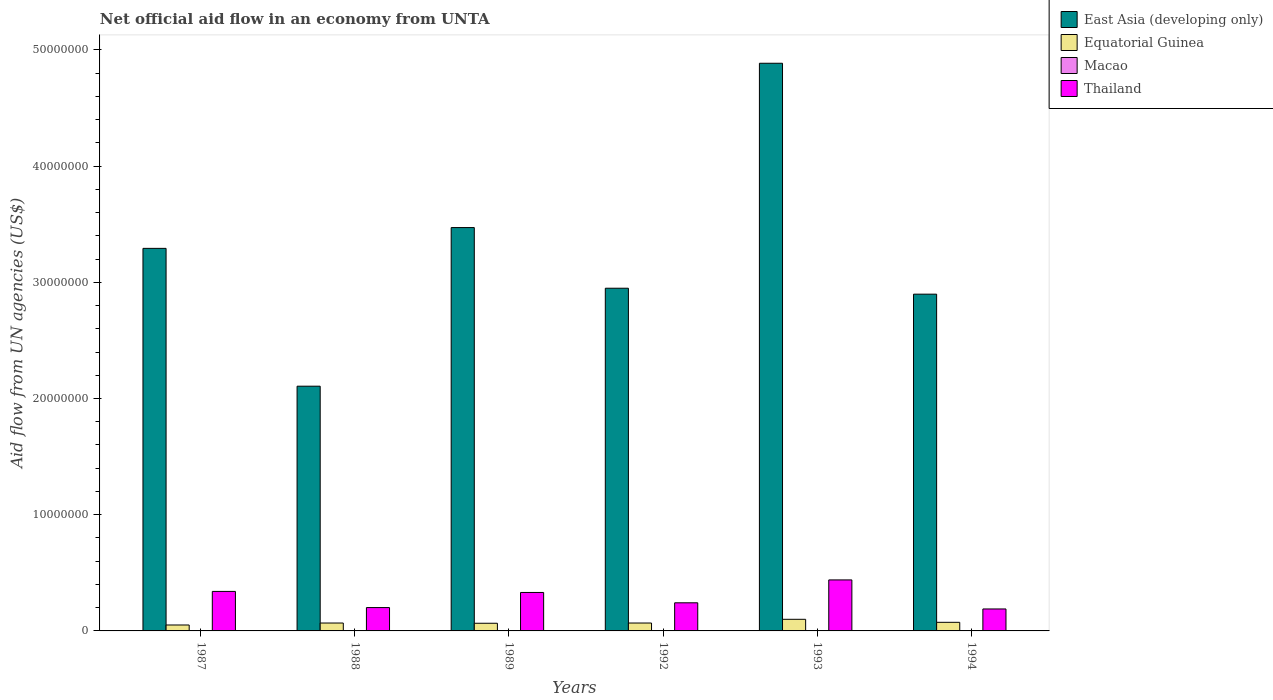How many different coloured bars are there?
Your response must be concise. 4. Are the number of bars on each tick of the X-axis equal?
Provide a short and direct response. Yes. How many bars are there on the 6th tick from the left?
Your answer should be very brief. 4. What is the net official aid flow in Thailand in 1987?
Your response must be concise. 3.40e+06. Across all years, what is the maximum net official aid flow in Thailand?
Provide a short and direct response. 4.39e+06. Across all years, what is the minimum net official aid flow in East Asia (developing only)?
Make the answer very short. 2.11e+07. In which year was the net official aid flow in Macao maximum?
Your response must be concise. 1987. What is the total net official aid flow in Macao in the graph?
Offer a terse response. 1.50e+05. What is the difference between the net official aid flow in Macao in 1987 and that in 1989?
Offer a very short reply. 0. What is the difference between the net official aid flow in Macao in 1988 and the net official aid flow in Thailand in 1989?
Your answer should be very brief. -3.28e+06. What is the average net official aid flow in East Asia (developing only) per year?
Your response must be concise. 3.27e+07. In the year 1989, what is the difference between the net official aid flow in Thailand and net official aid flow in Equatorial Guinea?
Give a very brief answer. 2.65e+06. In how many years, is the net official aid flow in Macao greater than 36000000 US$?
Your answer should be very brief. 0. Is the difference between the net official aid flow in Thailand in 1988 and 1989 greater than the difference between the net official aid flow in Equatorial Guinea in 1988 and 1989?
Keep it short and to the point. No. What is the difference between the highest and the second highest net official aid flow in Thailand?
Offer a very short reply. 9.90e+05. What is the difference between the highest and the lowest net official aid flow in East Asia (developing only)?
Ensure brevity in your answer.  2.78e+07. Is the sum of the net official aid flow in Equatorial Guinea in 1987 and 1992 greater than the maximum net official aid flow in Macao across all years?
Your response must be concise. Yes. Is it the case that in every year, the sum of the net official aid flow in East Asia (developing only) and net official aid flow in Thailand is greater than the sum of net official aid flow in Equatorial Guinea and net official aid flow in Macao?
Ensure brevity in your answer.  Yes. What does the 2nd bar from the left in 1993 represents?
Your answer should be compact. Equatorial Guinea. What does the 2nd bar from the right in 1988 represents?
Make the answer very short. Macao. How many bars are there?
Give a very brief answer. 24. What is the difference between two consecutive major ticks on the Y-axis?
Make the answer very short. 1.00e+07. Does the graph contain any zero values?
Offer a terse response. No. Does the graph contain grids?
Provide a succinct answer. No. How are the legend labels stacked?
Provide a short and direct response. Vertical. What is the title of the graph?
Ensure brevity in your answer.  Net official aid flow in an economy from UNTA. What is the label or title of the Y-axis?
Your answer should be compact. Aid flow from UN agencies (US$). What is the Aid flow from UN agencies (US$) in East Asia (developing only) in 1987?
Make the answer very short. 3.29e+07. What is the Aid flow from UN agencies (US$) of Equatorial Guinea in 1987?
Your answer should be very brief. 5.10e+05. What is the Aid flow from UN agencies (US$) in Macao in 1987?
Provide a short and direct response. 3.00e+04. What is the Aid flow from UN agencies (US$) of Thailand in 1987?
Make the answer very short. 3.40e+06. What is the Aid flow from UN agencies (US$) of East Asia (developing only) in 1988?
Keep it short and to the point. 2.11e+07. What is the Aid flow from UN agencies (US$) of Equatorial Guinea in 1988?
Your answer should be compact. 6.80e+05. What is the Aid flow from UN agencies (US$) in Macao in 1988?
Make the answer very short. 3.00e+04. What is the Aid flow from UN agencies (US$) in Thailand in 1988?
Your response must be concise. 2.01e+06. What is the Aid flow from UN agencies (US$) in East Asia (developing only) in 1989?
Make the answer very short. 3.47e+07. What is the Aid flow from UN agencies (US$) in Equatorial Guinea in 1989?
Your answer should be very brief. 6.60e+05. What is the Aid flow from UN agencies (US$) of Macao in 1989?
Provide a short and direct response. 3.00e+04. What is the Aid flow from UN agencies (US$) in Thailand in 1989?
Make the answer very short. 3.31e+06. What is the Aid flow from UN agencies (US$) of East Asia (developing only) in 1992?
Keep it short and to the point. 2.95e+07. What is the Aid flow from UN agencies (US$) of Equatorial Guinea in 1992?
Offer a very short reply. 6.80e+05. What is the Aid flow from UN agencies (US$) in Thailand in 1992?
Your answer should be very brief. 2.42e+06. What is the Aid flow from UN agencies (US$) of East Asia (developing only) in 1993?
Keep it short and to the point. 4.88e+07. What is the Aid flow from UN agencies (US$) of Equatorial Guinea in 1993?
Make the answer very short. 1.00e+06. What is the Aid flow from UN agencies (US$) of Macao in 1993?
Ensure brevity in your answer.  3.00e+04. What is the Aid flow from UN agencies (US$) in Thailand in 1993?
Provide a succinct answer. 4.39e+06. What is the Aid flow from UN agencies (US$) in East Asia (developing only) in 1994?
Keep it short and to the point. 2.90e+07. What is the Aid flow from UN agencies (US$) in Equatorial Guinea in 1994?
Your answer should be very brief. 7.40e+05. What is the Aid flow from UN agencies (US$) of Macao in 1994?
Give a very brief answer. 2.00e+04. What is the Aid flow from UN agencies (US$) of Thailand in 1994?
Keep it short and to the point. 1.89e+06. Across all years, what is the maximum Aid flow from UN agencies (US$) in East Asia (developing only)?
Your answer should be compact. 4.88e+07. Across all years, what is the maximum Aid flow from UN agencies (US$) in Thailand?
Provide a short and direct response. 4.39e+06. Across all years, what is the minimum Aid flow from UN agencies (US$) in East Asia (developing only)?
Provide a succinct answer. 2.11e+07. Across all years, what is the minimum Aid flow from UN agencies (US$) of Equatorial Guinea?
Make the answer very short. 5.10e+05. Across all years, what is the minimum Aid flow from UN agencies (US$) in Thailand?
Offer a terse response. 1.89e+06. What is the total Aid flow from UN agencies (US$) of East Asia (developing only) in the graph?
Ensure brevity in your answer.  1.96e+08. What is the total Aid flow from UN agencies (US$) of Equatorial Guinea in the graph?
Your answer should be compact. 4.27e+06. What is the total Aid flow from UN agencies (US$) of Macao in the graph?
Give a very brief answer. 1.50e+05. What is the total Aid flow from UN agencies (US$) of Thailand in the graph?
Provide a succinct answer. 1.74e+07. What is the difference between the Aid flow from UN agencies (US$) in East Asia (developing only) in 1987 and that in 1988?
Your response must be concise. 1.19e+07. What is the difference between the Aid flow from UN agencies (US$) in Thailand in 1987 and that in 1988?
Your answer should be very brief. 1.39e+06. What is the difference between the Aid flow from UN agencies (US$) in East Asia (developing only) in 1987 and that in 1989?
Keep it short and to the point. -1.79e+06. What is the difference between the Aid flow from UN agencies (US$) in Macao in 1987 and that in 1989?
Provide a short and direct response. 0. What is the difference between the Aid flow from UN agencies (US$) of East Asia (developing only) in 1987 and that in 1992?
Offer a very short reply. 3.43e+06. What is the difference between the Aid flow from UN agencies (US$) in Equatorial Guinea in 1987 and that in 1992?
Provide a succinct answer. -1.70e+05. What is the difference between the Aid flow from UN agencies (US$) of Thailand in 1987 and that in 1992?
Your answer should be very brief. 9.80e+05. What is the difference between the Aid flow from UN agencies (US$) of East Asia (developing only) in 1987 and that in 1993?
Provide a short and direct response. -1.59e+07. What is the difference between the Aid flow from UN agencies (US$) of Equatorial Guinea in 1987 and that in 1993?
Make the answer very short. -4.90e+05. What is the difference between the Aid flow from UN agencies (US$) in Thailand in 1987 and that in 1993?
Give a very brief answer. -9.90e+05. What is the difference between the Aid flow from UN agencies (US$) in East Asia (developing only) in 1987 and that in 1994?
Give a very brief answer. 3.94e+06. What is the difference between the Aid flow from UN agencies (US$) in Macao in 1987 and that in 1994?
Offer a terse response. 10000. What is the difference between the Aid flow from UN agencies (US$) of Thailand in 1987 and that in 1994?
Your answer should be compact. 1.51e+06. What is the difference between the Aid flow from UN agencies (US$) of East Asia (developing only) in 1988 and that in 1989?
Your response must be concise. -1.36e+07. What is the difference between the Aid flow from UN agencies (US$) of Equatorial Guinea in 1988 and that in 1989?
Your response must be concise. 2.00e+04. What is the difference between the Aid flow from UN agencies (US$) in Thailand in 1988 and that in 1989?
Make the answer very short. -1.30e+06. What is the difference between the Aid flow from UN agencies (US$) of East Asia (developing only) in 1988 and that in 1992?
Your answer should be compact. -8.43e+06. What is the difference between the Aid flow from UN agencies (US$) of Equatorial Guinea in 1988 and that in 1992?
Keep it short and to the point. 0. What is the difference between the Aid flow from UN agencies (US$) of Thailand in 1988 and that in 1992?
Ensure brevity in your answer.  -4.10e+05. What is the difference between the Aid flow from UN agencies (US$) of East Asia (developing only) in 1988 and that in 1993?
Offer a very short reply. -2.78e+07. What is the difference between the Aid flow from UN agencies (US$) of Equatorial Guinea in 1988 and that in 1993?
Your response must be concise. -3.20e+05. What is the difference between the Aid flow from UN agencies (US$) of Macao in 1988 and that in 1993?
Provide a succinct answer. 0. What is the difference between the Aid flow from UN agencies (US$) in Thailand in 1988 and that in 1993?
Offer a terse response. -2.38e+06. What is the difference between the Aid flow from UN agencies (US$) of East Asia (developing only) in 1988 and that in 1994?
Provide a short and direct response. -7.92e+06. What is the difference between the Aid flow from UN agencies (US$) in Macao in 1988 and that in 1994?
Offer a very short reply. 10000. What is the difference between the Aid flow from UN agencies (US$) of Thailand in 1988 and that in 1994?
Provide a succinct answer. 1.20e+05. What is the difference between the Aid flow from UN agencies (US$) in East Asia (developing only) in 1989 and that in 1992?
Give a very brief answer. 5.22e+06. What is the difference between the Aid flow from UN agencies (US$) in Thailand in 1989 and that in 1992?
Your response must be concise. 8.90e+05. What is the difference between the Aid flow from UN agencies (US$) in East Asia (developing only) in 1989 and that in 1993?
Your answer should be compact. -1.41e+07. What is the difference between the Aid flow from UN agencies (US$) of Macao in 1989 and that in 1993?
Make the answer very short. 0. What is the difference between the Aid flow from UN agencies (US$) in Thailand in 1989 and that in 1993?
Keep it short and to the point. -1.08e+06. What is the difference between the Aid flow from UN agencies (US$) of East Asia (developing only) in 1989 and that in 1994?
Make the answer very short. 5.73e+06. What is the difference between the Aid flow from UN agencies (US$) of Equatorial Guinea in 1989 and that in 1994?
Provide a succinct answer. -8.00e+04. What is the difference between the Aid flow from UN agencies (US$) of Thailand in 1989 and that in 1994?
Your answer should be compact. 1.42e+06. What is the difference between the Aid flow from UN agencies (US$) in East Asia (developing only) in 1992 and that in 1993?
Give a very brief answer. -1.94e+07. What is the difference between the Aid flow from UN agencies (US$) of Equatorial Guinea in 1992 and that in 1993?
Offer a terse response. -3.20e+05. What is the difference between the Aid flow from UN agencies (US$) in Thailand in 1992 and that in 1993?
Your answer should be compact. -1.97e+06. What is the difference between the Aid flow from UN agencies (US$) of East Asia (developing only) in 1992 and that in 1994?
Give a very brief answer. 5.10e+05. What is the difference between the Aid flow from UN agencies (US$) of Thailand in 1992 and that in 1994?
Your response must be concise. 5.30e+05. What is the difference between the Aid flow from UN agencies (US$) of East Asia (developing only) in 1993 and that in 1994?
Ensure brevity in your answer.  1.99e+07. What is the difference between the Aid flow from UN agencies (US$) in Thailand in 1993 and that in 1994?
Give a very brief answer. 2.50e+06. What is the difference between the Aid flow from UN agencies (US$) of East Asia (developing only) in 1987 and the Aid flow from UN agencies (US$) of Equatorial Guinea in 1988?
Your answer should be compact. 3.22e+07. What is the difference between the Aid flow from UN agencies (US$) of East Asia (developing only) in 1987 and the Aid flow from UN agencies (US$) of Macao in 1988?
Provide a succinct answer. 3.29e+07. What is the difference between the Aid flow from UN agencies (US$) of East Asia (developing only) in 1987 and the Aid flow from UN agencies (US$) of Thailand in 1988?
Keep it short and to the point. 3.09e+07. What is the difference between the Aid flow from UN agencies (US$) in Equatorial Guinea in 1987 and the Aid flow from UN agencies (US$) in Macao in 1988?
Offer a terse response. 4.80e+05. What is the difference between the Aid flow from UN agencies (US$) of Equatorial Guinea in 1987 and the Aid flow from UN agencies (US$) of Thailand in 1988?
Your response must be concise. -1.50e+06. What is the difference between the Aid flow from UN agencies (US$) of Macao in 1987 and the Aid flow from UN agencies (US$) of Thailand in 1988?
Your answer should be very brief. -1.98e+06. What is the difference between the Aid flow from UN agencies (US$) in East Asia (developing only) in 1987 and the Aid flow from UN agencies (US$) in Equatorial Guinea in 1989?
Give a very brief answer. 3.23e+07. What is the difference between the Aid flow from UN agencies (US$) of East Asia (developing only) in 1987 and the Aid flow from UN agencies (US$) of Macao in 1989?
Offer a very short reply. 3.29e+07. What is the difference between the Aid flow from UN agencies (US$) of East Asia (developing only) in 1987 and the Aid flow from UN agencies (US$) of Thailand in 1989?
Make the answer very short. 2.96e+07. What is the difference between the Aid flow from UN agencies (US$) in Equatorial Guinea in 1987 and the Aid flow from UN agencies (US$) in Macao in 1989?
Provide a short and direct response. 4.80e+05. What is the difference between the Aid flow from UN agencies (US$) in Equatorial Guinea in 1987 and the Aid flow from UN agencies (US$) in Thailand in 1989?
Your response must be concise. -2.80e+06. What is the difference between the Aid flow from UN agencies (US$) in Macao in 1987 and the Aid flow from UN agencies (US$) in Thailand in 1989?
Give a very brief answer. -3.28e+06. What is the difference between the Aid flow from UN agencies (US$) of East Asia (developing only) in 1987 and the Aid flow from UN agencies (US$) of Equatorial Guinea in 1992?
Ensure brevity in your answer.  3.22e+07. What is the difference between the Aid flow from UN agencies (US$) in East Asia (developing only) in 1987 and the Aid flow from UN agencies (US$) in Macao in 1992?
Your answer should be very brief. 3.29e+07. What is the difference between the Aid flow from UN agencies (US$) of East Asia (developing only) in 1987 and the Aid flow from UN agencies (US$) of Thailand in 1992?
Your response must be concise. 3.05e+07. What is the difference between the Aid flow from UN agencies (US$) in Equatorial Guinea in 1987 and the Aid flow from UN agencies (US$) in Macao in 1992?
Provide a succinct answer. 5.00e+05. What is the difference between the Aid flow from UN agencies (US$) of Equatorial Guinea in 1987 and the Aid flow from UN agencies (US$) of Thailand in 1992?
Offer a very short reply. -1.91e+06. What is the difference between the Aid flow from UN agencies (US$) of Macao in 1987 and the Aid flow from UN agencies (US$) of Thailand in 1992?
Offer a terse response. -2.39e+06. What is the difference between the Aid flow from UN agencies (US$) of East Asia (developing only) in 1987 and the Aid flow from UN agencies (US$) of Equatorial Guinea in 1993?
Give a very brief answer. 3.19e+07. What is the difference between the Aid flow from UN agencies (US$) in East Asia (developing only) in 1987 and the Aid flow from UN agencies (US$) in Macao in 1993?
Ensure brevity in your answer.  3.29e+07. What is the difference between the Aid flow from UN agencies (US$) in East Asia (developing only) in 1987 and the Aid flow from UN agencies (US$) in Thailand in 1993?
Give a very brief answer. 2.85e+07. What is the difference between the Aid flow from UN agencies (US$) of Equatorial Guinea in 1987 and the Aid flow from UN agencies (US$) of Macao in 1993?
Keep it short and to the point. 4.80e+05. What is the difference between the Aid flow from UN agencies (US$) in Equatorial Guinea in 1987 and the Aid flow from UN agencies (US$) in Thailand in 1993?
Ensure brevity in your answer.  -3.88e+06. What is the difference between the Aid flow from UN agencies (US$) in Macao in 1987 and the Aid flow from UN agencies (US$) in Thailand in 1993?
Make the answer very short. -4.36e+06. What is the difference between the Aid flow from UN agencies (US$) of East Asia (developing only) in 1987 and the Aid flow from UN agencies (US$) of Equatorial Guinea in 1994?
Your response must be concise. 3.22e+07. What is the difference between the Aid flow from UN agencies (US$) in East Asia (developing only) in 1987 and the Aid flow from UN agencies (US$) in Macao in 1994?
Your response must be concise. 3.29e+07. What is the difference between the Aid flow from UN agencies (US$) of East Asia (developing only) in 1987 and the Aid flow from UN agencies (US$) of Thailand in 1994?
Provide a succinct answer. 3.10e+07. What is the difference between the Aid flow from UN agencies (US$) in Equatorial Guinea in 1987 and the Aid flow from UN agencies (US$) in Macao in 1994?
Give a very brief answer. 4.90e+05. What is the difference between the Aid flow from UN agencies (US$) in Equatorial Guinea in 1987 and the Aid flow from UN agencies (US$) in Thailand in 1994?
Give a very brief answer. -1.38e+06. What is the difference between the Aid flow from UN agencies (US$) of Macao in 1987 and the Aid flow from UN agencies (US$) of Thailand in 1994?
Offer a terse response. -1.86e+06. What is the difference between the Aid flow from UN agencies (US$) of East Asia (developing only) in 1988 and the Aid flow from UN agencies (US$) of Equatorial Guinea in 1989?
Offer a very short reply. 2.04e+07. What is the difference between the Aid flow from UN agencies (US$) of East Asia (developing only) in 1988 and the Aid flow from UN agencies (US$) of Macao in 1989?
Your answer should be compact. 2.10e+07. What is the difference between the Aid flow from UN agencies (US$) of East Asia (developing only) in 1988 and the Aid flow from UN agencies (US$) of Thailand in 1989?
Give a very brief answer. 1.78e+07. What is the difference between the Aid flow from UN agencies (US$) of Equatorial Guinea in 1988 and the Aid flow from UN agencies (US$) of Macao in 1989?
Provide a short and direct response. 6.50e+05. What is the difference between the Aid flow from UN agencies (US$) of Equatorial Guinea in 1988 and the Aid flow from UN agencies (US$) of Thailand in 1989?
Offer a very short reply. -2.63e+06. What is the difference between the Aid flow from UN agencies (US$) of Macao in 1988 and the Aid flow from UN agencies (US$) of Thailand in 1989?
Offer a very short reply. -3.28e+06. What is the difference between the Aid flow from UN agencies (US$) of East Asia (developing only) in 1988 and the Aid flow from UN agencies (US$) of Equatorial Guinea in 1992?
Offer a terse response. 2.04e+07. What is the difference between the Aid flow from UN agencies (US$) of East Asia (developing only) in 1988 and the Aid flow from UN agencies (US$) of Macao in 1992?
Provide a short and direct response. 2.10e+07. What is the difference between the Aid flow from UN agencies (US$) in East Asia (developing only) in 1988 and the Aid flow from UN agencies (US$) in Thailand in 1992?
Provide a succinct answer. 1.86e+07. What is the difference between the Aid flow from UN agencies (US$) of Equatorial Guinea in 1988 and the Aid flow from UN agencies (US$) of Macao in 1992?
Provide a succinct answer. 6.70e+05. What is the difference between the Aid flow from UN agencies (US$) in Equatorial Guinea in 1988 and the Aid flow from UN agencies (US$) in Thailand in 1992?
Offer a very short reply. -1.74e+06. What is the difference between the Aid flow from UN agencies (US$) in Macao in 1988 and the Aid flow from UN agencies (US$) in Thailand in 1992?
Keep it short and to the point. -2.39e+06. What is the difference between the Aid flow from UN agencies (US$) in East Asia (developing only) in 1988 and the Aid flow from UN agencies (US$) in Equatorial Guinea in 1993?
Provide a succinct answer. 2.01e+07. What is the difference between the Aid flow from UN agencies (US$) of East Asia (developing only) in 1988 and the Aid flow from UN agencies (US$) of Macao in 1993?
Provide a short and direct response. 2.10e+07. What is the difference between the Aid flow from UN agencies (US$) of East Asia (developing only) in 1988 and the Aid flow from UN agencies (US$) of Thailand in 1993?
Provide a succinct answer. 1.67e+07. What is the difference between the Aid flow from UN agencies (US$) of Equatorial Guinea in 1988 and the Aid flow from UN agencies (US$) of Macao in 1993?
Your answer should be compact. 6.50e+05. What is the difference between the Aid flow from UN agencies (US$) in Equatorial Guinea in 1988 and the Aid flow from UN agencies (US$) in Thailand in 1993?
Make the answer very short. -3.71e+06. What is the difference between the Aid flow from UN agencies (US$) in Macao in 1988 and the Aid flow from UN agencies (US$) in Thailand in 1993?
Make the answer very short. -4.36e+06. What is the difference between the Aid flow from UN agencies (US$) of East Asia (developing only) in 1988 and the Aid flow from UN agencies (US$) of Equatorial Guinea in 1994?
Provide a succinct answer. 2.03e+07. What is the difference between the Aid flow from UN agencies (US$) of East Asia (developing only) in 1988 and the Aid flow from UN agencies (US$) of Macao in 1994?
Offer a terse response. 2.10e+07. What is the difference between the Aid flow from UN agencies (US$) in East Asia (developing only) in 1988 and the Aid flow from UN agencies (US$) in Thailand in 1994?
Make the answer very short. 1.92e+07. What is the difference between the Aid flow from UN agencies (US$) in Equatorial Guinea in 1988 and the Aid flow from UN agencies (US$) in Thailand in 1994?
Provide a succinct answer. -1.21e+06. What is the difference between the Aid flow from UN agencies (US$) in Macao in 1988 and the Aid flow from UN agencies (US$) in Thailand in 1994?
Provide a short and direct response. -1.86e+06. What is the difference between the Aid flow from UN agencies (US$) in East Asia (developing only) in 1989 and the Aid flow from UN agencies (US$) in Equatorial Guinea in 1992?
Make the answer very short. 3.40e+07. What is the difference between the Aid flow from UN agencies (US$) of East Asia (developing only) in 1989 and the Aid flow from UN agencies (US$) of Macao in 1992?
Provide a succinct answer. 3.47e+07. What is the difference between the Aid flow from UN agencies (US$) in East Asia (developing only) in 1989 and the Aid flow from UN agencies (US$) in Thailand in 1992?
Offer a very short reply. 3.23e+07. What is the difference between the Aid flow from UN agencies (US$) of Equatorial Guinea in 1989 and the Aid flow from UN agencies (US$) of Macao in 1992?
Make the answer very short. 6.50e+05. What is the difference between the Aid flow from UN agencies (US$) in Equatorial Guinea in 1989 and the Aid flow from UN agencies (US$) in Thailand in 1992?
Provide a short and direct response. -1.76e+06. What is the difference between the Aid flow from UN agencies (US$) in Macao in 1989 and the Aid flow from UN agencies (US$) in Thailand in 1992?
Your response must be concise. -2.39e+06. What is the difference between the Aid flow from UN agencies (US$) of East Asia (developing only) in 1989 and the Aid flow from UN agencies (US$) of Equatorial Guinea in 1993?
Make the answer very short. 3.37e+07. What is the difference between the Aid flow from UN agencies (US$) in East Asia (developing only) in 1989 and the Aid flow from UN agencies (US$) in Macao in 1993?
Provide a short and direct response. 3.47e+07. What is the difference between the Aid flow from UN agencies (US$) of East Asia (developing only) in 1989 and the Aid flow from UN agencies (US$) of Thailand in 1993?
Your answer should be very brief. 3.03e+07. What is the difference between the Aid flow from UN agencies (US$) in Equatorial Guinea in 1989 and the Aid flow from UN agencies (US$) in Macao in 1993?
Ensure brevity in your answer.  6.30e+05. What is the difference between the Aid flow from UN agencies (US$) in Equatorial Guinea in 1989 and the Aid flow from UN agencies (US$) in Thailand in 1993?
Your response must be concise. -3.73e+06. What is the difference between the Aid flow from UN agencies (US$) of Macao in 1989 and the Aid flow from UN agencies (US$) of Thailand in 1993?
Offer a terse response. -4.36e+06. What is the difference between the Aid flow from UN agencies (US$) in East Asia (developing only) in 1989 and the Aid flow from UN agencies (US$) in Equatorial Guinea in 1994?
Keep it short and to the point. 3.40e+07. What is the difference between the Aid flow from UN agencies (US$) in East Asia (developing only) in 1989 and the Aid flow from UN agencies (US$) in Macao in 1994?
Provide a succinct answer. 3.47e+07. What is the difference between the Aid flow from UN agencies (US$) in East Asia (developing only) in 1989 and the Aid flow from UN agencies (US$) in Thailand in 1994?
Make the answer very short. 3.28e+07. What is the difference between the Aid flow from UN agencies (US$) of Equatorial Guinea in 1989 and the Aid flow from UN agencies (US$) of Macao in 1994?
Give a very brief answer. 6.40e+05. What is the difference between the Aid flow from UN agencies (US$) in Equatorial Guinea in 1989 and the Aid flow from UN agencies (US$) in Thailand in 1994?
Your answer should be very brief. -1.23e+06. What is the difference between the Aid flow from UN agencies (US$) in Macao in 1989 and the Aid flow from UN agencies (US$) in Thailand in 1994?
Keep it short and to the point. -1.86e+06. What is the difference between the Aid flow from UN agencies (US$) in East Asia (developing only) in 1992 and the Aid flow from UN agencies (US$) in Equatorial Guinea in 1993?
Keep it short and to the point. 2.85e+07. What is the difference between the Aid flow from UN agencies (US$) of East Asia (developing only) in 1992 and the Aid flow from UN agencies (US$) of Macao in 1993?
Your answer should be compact. 2.95e+07. What is the difference between the Aid flow from UN agencies (US$) of East Asia (developing only) in 1992 and the Aid flow from UN agencies (US$) of Thailand in 1993?
Give a very brief answer. 2.51e+07. What is the difference between the Aid flow from UN agencies (US$) of Equatorial Guinea in 1992 and the Aid flow from UN agencies (US$) of Macao in 1993?
Keep it short and to the point. 6.50e+05. What is the difference between the Aid flow from UN agencies (US$) of Equatorial Guinea in 1992 and the Aid flow from UN agencies (US$) of Thailand in 1993?
Offer a terse response. -3.71e+06. What is the difference between the Aid flow from UN agencies (US$) of Macao in 1992 and the Aid flow from UN agencies (US$) of Thailand in 1993?
Your response must be concise. -4.38e+06. What is the difference between the Aid flow from UN agencies (US$) of East Asia (developing only) in 1992 and the Aid flow from UN agencies (US$) of Equatorial Guinea in 1994?
Your answer should be very brief. 2.88e+07. What is the difference between the Aid flow from UN agencies (US$) in East Asia (developing only) in 1992 and the Aid flow from UN agencies (US$) in Macao in 1994?
Ensure brevity in your answer.  2.95e+07. What is the difference between the Aid flow from UN agencies (US$) in East Asia (developing only) in 1992 and the Aid flow from UN agencies (US$) in Thailand in 1994?
Your response must be concise. 2.76e+07. What is the difference between the Aid flow from UN agencies (US$) of Equatorial Guinea in 1992 and the Aid flow from UN agencies (US$) of Macao in 1994?
Your response must be concise. 6.60e+05. What is the difference between the Aid flow from UN agencies (US$) of Equatorial Guinea in 1992 and the Aid flow from UN agencies (US$) of Thailand in 1994?
Provide a succinct answer. -1.21e+06. What is the difference between the Aid flow from UN agencies (US$) in Macao in 1992 and the Aid flow from UN agencies (US$) in Thailand in 1994?
Keep it short and to the point. -1.88e+06. What is the difference between the Aid flow from UN agencies (US$) of East Asia (developing only) in 1993 and the Aid flow from UN agencies (US$) of Equatorial Guinea in 1994?
Offer a very short reply. 4.81e+07. What is the difference between the Aid flow from UN agencies (US$) of East Asia (developing only) in 1993 and the Aid flow from UN agencies (US$) of Macao in 1994?
Your answer should be very brief. 4.88e+07. What is the difference between the Aid flow from UN agencies (US$) in East Asia (developing only) in 1993 and the Aid flow from UN agencies (US$) in Thailand in 1994?
Keep it short and to the point. 4.70e+07. What is the difference between the Aid flow from UN agencies (US$) of Equatorial Guinea in 1993 and the Aid flow from UN agencies (US$) of Macao in 1994?
Your response must be concise. 9.80e+05. What is the difference between the Aid flow from UN agencies (US$) in Equatorial Guinea in 1993 and the Aid flow from UN agencies (US$) in Thailand in 1994?
Your answer should be compact. -8.90e+05. What is the difference between the Aid flow from UN agencies (US$) of Macao in 1993 and the Aid flow from UN agencies (US$) of Thailand in 1994?
Your response must be concise. -1.86e+06. What is the average Aid flow from UN agencies (US$) in East Asia (developing only) per year?
Keep it short and to the point. 3.27e+07. What is the average Aid flow from UN agencies (US$) of Equatorial Guinea per year?
Give a very brief answer. 7.12e+05. What is the average Aid flow from UN agencies (US$) in Macao per year?
Ensure brevity in your answer.  2.50e+04. What is the average Aid flow from UN agencies (US$) of Thailand per year?
Your answer should be compact. 2.90e+06. In the year 1987, what is the difference between the Aid flow from UN agencies (US$) of East Asia (developing only) and Aid flow from UN agencies (US$) of Equatorial Guinea?
Give a very brief answer. 3.24e+07. In the year 1987, what is the difference between the Aid flow from UN agencies (US$) of East Asia (developing only) and Aid flow from UN agencies (US$) of Macao?
Keep it short and to the point. 3.29e+07. In the year 1987, what is the difference between the Aid flow from UN agencies (US$) in East Asia (developing only) and Aid flow from UN agencies (US$) in Thailand?
Offer a very short reply. 2.95e+07. In the year 1987, what is the difference between the Aid flow from UN agencies (US$) in Equatorial Guinea and Aid flow from UN agencies (US$) in Thailand?
Offer a terse response. -2.89e+06. In the year 1987, what is the difference between the Aid flow from UN agencies (US$) of Macao and Aid flow from UN agencies (US$) of Thailand?
Your response must be concise. -3.37e+06. In the year 1988, what is the difference between the Aid flow from UN agencies (US$) in East Asia (developing only) and Aid flow from UN agencies (US$) in Equatorial Guinea?
Make the answer very short. 2.04e+07. In the year 1988, what is the difference between the Aid flow from UN agencies (US$) of East Asia (developing only) and Aid flow from UN agencies (US$) of Macao?
Provide a short and direct response. 2.10e+07. In the year 1988, what is the difference between the Aid flow from UN agencies (US$) in East Asia (developing only) and Aid flow from UN agencies (US$) in Thailand?
Keep it short and to the point. 1.90e+07. In the year 1988, what is the difference between the Aid flow from UN agencies (US$) in Equatorial Guinea and Aid flow from UN agencies (US$) in Macao?
Your answer should be very brief. 6.50e+05. In the year 1988, what is the difference between the Aid flow from UN agencies (US$) of Equatorial Guinea and Aid flow from UN agencies (US$) of Thailand?
Your response must be concise. -1.33e+06. In the year 1988, what is the difference between the Aid flow from UN agencies (US$) in Macao and Aid flow from UN agencies (US$) in Thailand?
Your answer should be compact. -1.98e+06. In the year 1989, what is the difference between the Aid flow from UN agencies (US$) of East Asia (developing only) and Aid flow from UN agencies (US$) of Equatorial Guinea?
Your answer should be compact. 3.40e+07. In the year 1989, what is the difference between the Aid flow from UN agencies (US$) in East Asia (developing only) and Aid flow from UN agencies (US$) in Macao?
Your response must be concise. 3.47e+07. In the year 1989, what is the difference between the Aid flow from UN agencies (US$) in East Asia (developing only) and Aid flow from UN agencies (US$) in Thailand?
Ensure brevity in your answer.  3.14e+07. In the year 1989, what is the difference between the Aid flow from UN agencies (US$) in Equatorial Guinea and Aid flow from UN agencies (US$) in Macao?
Your answer should be very brief. 6.30e+05. In the year 1989, what is the difference between the Aid flow from UN agencies (US$) of Equatorial Guinea and Aid flow from UN agencies (US$) of Thailand?
Provide a succinct answer. -2.65e+06. In the year 1989, what is the difference between the Aid flow from UN agencies (US$) in Macao and Aid flow from UN agencies (US$) in Thailand?
Provide a short and direct response. -3.28e+06. In the year 1992, what is the difference between the Aid flow from UN agencies (US$) of East Asia (developing only) and Aid flow from UN agencies (US$) of Equatorial Guinea?
Offer a very short reply. 2.88e+07. In the year 1992, what is the difference between the Aid flow from UN agencies (US$) of East Asia (developing only) and Aid flow from UN agencies (US$) of Macao?
Provide a short and direct response. 2.95e+07. In the year 1992, what is the difference between the Aid flow from UN agencies (US$) of East Asia (developing only) and Aid flow from UN agencies (US$) of Thailand?
Your answer should be very brief. 2.71e+07. In the year 1992, what is the difference between the Aid flow from UN agencies (US$) in Equatorial Guinea and Aid flow from UN agencies (US$) in Macao?
Give a very brief answer. 6.70e+05. In the year 1992, what is the difference between the Aid flow from UN agencies (US$) of Equatorial Guinea and Aid flow from UN agencies (US$) of Thailand?
Offer a very short reply. -1.74e+06. In the year 1992, what is the difference between the Aid flow from UN agencies (US$) in Macao and Aid flow from UN agencies (US$) in Thailand?
Ensure brevity in your answer.  -2.41e+06. In the year 1993, what is the difference between the Aid flow from UN agencies (US$) in East Asia (developing only) and Aid flow from UN agencies (US$) in Equatorial Guinea?
Provide a succinct answer. 4.78e+07. In the year 1993, what is the difference between the Aid flow from UN agencies (US$) in East Asia (developing only) and Aid flow from UN agencies (US$) in Macao?
Offer a very short reply. 4.88e+07. In the year 1993, what is the difference between the Aid flow from UN agencies (US$) in East Asia (developing only) and Aid flow from UN agencies (US$) in Thailand?
Offer a terse response. 4.45e+07. In the year 1993, what is the difference between the Aid flow from UN agencies (US$) of Equatorial Guinea and Aid flow from UN agencies (US$) of Macao?
Your answer should be compact. 9.70e+05. In the year 1993, what is the difference between the Aid flow from UN agencies (US$) of Equatorial Guinea and Aid flow from UN agencies (US$) of Thailand?
Provide a succinct answer. -3.39e+06. In the year 1993, what is the difference between the Aid flow from UN agencies (US$) in Macao and Aid flow from UN agencies (US$) in Thailand?
Make the answer very short. -4.36e+06. In the year 1994, what is the difference between the Aid flow from UN agencies (US$) of East Asia (developing only) and Aid flow from UN agencies (US$) of Equatorial Guinea?
Give a very brief answer. 2.82e+07. In the year 1994, what is the difference between the Aid flow from UN agencies (US$) of East Asia (developing only) and Aid flow from UN agencies (US$) of Macao?
Give a very brief answer. 2.90e+07. In the year 1994, what is the difference between the Aid flow from UN agencies (US$) in East Asia (developing only) and Aid flow from UN agencies (US$) in Thailand?
Your answer should be very brief. 2.71e+07. In the year 1994, what is the difference between the Aid flow from UN agencies (US$) of Equatorial Guinea and Aid flow from UN agencies (US$) of Macao?
Offer a very short reply. 7.20e+05. In the year 1994, what is the difference between the Aid flow from UN agencies (US$) in Equatorial Guinea and Aid flow from UN agencies (US$) in Thailand?
Your answer should be compact. -1.15e+06. In the year 1994, what is the difference between the Aid flow from UN agencies (US$) in Macao and Aid flow from UN agencies (US$) in Thailand?
Offer a terse response. -1.87e+06. What is the ratio of the Aid flow from UN agencies (US$) of East Asia (developing only) in 1987 to that in 1988?
Make the answer very short. 1.56. What is the ratio of the Aid flow from UN agencies (US$) in Equatorial Guinea in 1987 to that in 1988?
Offer a very short reply. 0.75. What is the ratio of the Aid flow from UN agencies (US$) of Macao in 1987 to that in 1988?
Your answer should be compact. 1. What is the ratio of the Aid flow from UN agencies (US$) in Thailand in 1987 to that in 1988?
Your response must be concise. 1.69. What is the ratio of the Aid flow from UN agencies (US$) in East Asia (developing only) in 1987 to that in 1989?
Ensure brevity in your answer.  0.95. What is the ratio of the Aid flow from UN agencies (US$) in Equatorial Guinea in 1987 to that in 1989?
Give a very brief answer. 0.77. What is the ratio of the Aid flow from UN agencies (US$) in Thailand in 1987 to that in 1989?
Ensure brevity in your answer.  1.03. What is the ratio of the Aid flow from UN agencies (US$) of East Asia (developing only) in 1987 to that in 1992?
Your response must be concise. 1.12. What is the ratio of the Aid flow from UN agencies (US$) in Macao in 1987 to that in 1992?
Offer a very short reply. 3. What is the ratio of the Aid flow from UN agencies (US$) of Thailand in 1987 to that in 1992?
Offer a terse response. 1.41. What is the ratio of the Aid flow from UN agencies (US$) in East Asia (developing only) in 1987 to that in 1993?
Provide a succinct answer. 0.67. What is the ratio of the Aid flow from UN agencies (US$) of Equatorial Guinea in 1987 to that in 1993?
Your answer should be compact. 0.51. What is the ratio of the Aid flow from UN agencies (US$) of Thailand in 1987 to that in 1993?
Make the answer very short. 0.77. What is the ratio of the Aid flow from UN agencies (US$) in East Asia (developing only) in 1987 to that in 1994?
Your answer should be compact. 1.14. What is the ratio of the Aid flow from UN agencies (US$) in Equatorial Guinea in 1987 to that in 1994?
Offer a terse response. 0.69. What is the ratio of the Aid flow from UN agencies (US$) of Macao in 1987 to that in 1994?
Offer a terse response. 1.5. What is the ratio of the Aid flow from UN agencies (US$) of Thailand in 1987 to that in 1994?
Your response must be concise. 1.8. What is the ratio of the Aid flow from UN agencies (US$) of East Asia (developing only) in 1988 to that in 1989?
Keep it short and to the point. 0.61. What is the ratio of the Aid flow from UN agencies (US$) of Equatorial Guinea in 1988 to that in 1989?
Ensure brevity in your answer.  1.03. What is the ratio of the Aid flow from UN agencies (US$) of Macao in 1988 to that in 1989?
Provide a short and direct response. 1. What is the ratio of the Aid flow from UN agencies (US$) of Thailand in 1988 to that in 1989?
Your answer should be compact. 0.61. What is the ratio of the Aid flow from UN agencies (US$) in East Asia (developing only) in 1988 to that in 1992?
Ensure brevity in your answer.  0.71. What is the ratio of the Aid flow from UN agencies (US$) of Thailand in 1988 to that in 1992?
Give a very brief answer. 0.83. What is the ratio of the Aid flow from UN agencies (US$) in East Asia (developing only) in 1988 to that in 1993?
Ensure brevity in your answer.  0.43. What is the ratio of the Aid flow from UN agencies (US$) in Equatorial Guinea in 1988 to that in 1993?
Your response must be concise. 0.68. What is the ratio of the Aid flow from UN agencies (US$) in Thailand in 1988 to that in 1993?
Your answer should be very brief. 0.46. What is the ratio of the Aid flow from UN agencies (US$) of East Asia (developing only) in 1988 to that in 1994?
Make the answer very short. 0.73. What is the ratio of the Aid flow from UN agencies (US$) in Equatorial Guinea in 1988 to that in 1994?
Your answer should be very brief. 0.92. What is the ratio of the Aid flow from UN agencies (US$) in Thailand in 1988 to that in 1994?
Your answer should be compact. 1.06. What is the ratio of the Aid flow from UN agencies (US$) in East Asia (developing only) in 1989 to that in 1992?
Your answer should be compact. 1.18. What is the ratio of the Aid flow from UN agencies (US$) in Equatorial Guinea in 1989 to that in 1992?
Your response must be concise. 0.97. What is the ratio of the Aid flow from UN agencies (US$) of Macao in 1989 to that in 1992?
Your answer should be very brief. 3. What is the ratio of the Aid flow from UN agencies (US$) of Thailand in 1989 to that in 1992?
Keep it short and to the point. 1.37. What is the ratio of the Aid flow from UN agencies (US$) of East Asia (developing only) in 1989 to that in 1993?
Your answer should be very brief. 0.71. What is the ratio of the Aid flow from UN agencies (US$) of Equatorial Guinea in 1989 to that in 1993?
Your answer should be compact. 0.66. What is the ratio of the Aid flow from UN agencies (US$) in Macao in 1989 to that in 1993?
Ensure brevity in your answer.  1. What is the ratio of the Aid flow from UN agencies (US$) in Thailand in 1989 to that in 1993?
Provide a short and direct response. 0.75. What is the ratio of the Aid flow from UN agencies (US$) in East Asia (developing only) in 1989 to that in 1994?
Your response must be concise. 1.2. What is the ratio of the Aid flow from UN agencies (US$) of Equatorial Guinea in 1989 to that in 1994?
Ensure brevity in your answer.  0.89. What is the ratio of the Aid flow from UN agencies (US$) in Thailand in 1989 to that in 1994?
Offer a terse response. 1.75. What is the ratio of the Aid flow from UN agencies (US$) of East Asia (developing only) in 1992 to that in 1993?
Give a very brief answer. 0.6. What is the ratio of the Aid flow from UN agencies (US$) of Equatorial Guinea in 1992 to that in 1993?
Your answer should be compact. 0.68. What is the ratio of the Aid flow from UN agencies (US$) in Thailand in 1992 to that in 1993?
Give a very brief answer. 0.55. What is the ratio of the Aid flow from UN agencies (US$) of East Asia (developing only) in 1992 to that in 1994?
Make the answer very short. 1.02. What is the ratio of the Aid flow from UN agencies (US$) in Equatorial Guinea in 1992 to that in 1994?
Offer a very short reply. 0.92. What is the ratio of the Aid flow from UN agencies (US$) of Macao in 1992 to that in 1994?
Offer a terse response. 0.5. What is the ratio of the Aid flow from UN agencies (US$) of Thailand in 1992 to that in 1994?
Provide a succinct answer. 1.28. What is the ratio of the Aid flow from UN agencies (US$) in East Asia (developing only) in 1993 to that in 1994?
Your response must be concise. 1.69. What is the ratio of the Aid flow from UN agencies (US$) of Equatorial Guinea in 1993 to that in 1994?
Provide a succinct answer. 1.35. What is the ratio of the Aid flow from UN agencies (US$) of Thailand in 1993 to that in 1994?
Keep it short and to the point. 2.32. What is the difference between the highest and the second highest Aid flow from UN agencies (US$) in East Asia (developing only)?
Keep it short and to the point. 1.41e+07. What is the difference between the highest and the second highest Aid flow from UN agencies (US$) in Equatorial Guinea?
Give a very brief answer. 2.60e+05. What is the difference between the highest and the second highest Aid flow from UN agencies (US$) in Thailand?
Your answer should be very brief. 9.90e+05. What is the difference between the highest and the lowest Aid flow from UN agencies (US$) in East Asia (developing only)?
Provide a succinct answer. 2.78e+07. What is the difference between the highest and the lowest Aid flow from UN agencies (US$) of Equatorial Guinea?
Make the answer very short. 4.90e+05. What is the difference between the highest and the lowest Aid flow from UN agencies (US$) of Macao?
Provide a short and direct response. 2.00e+04. What is the difference between the highest and the lowest Aid flow from UN agencies (US$) of Thailand?
Give a very brief answer. 2.50e+06. 